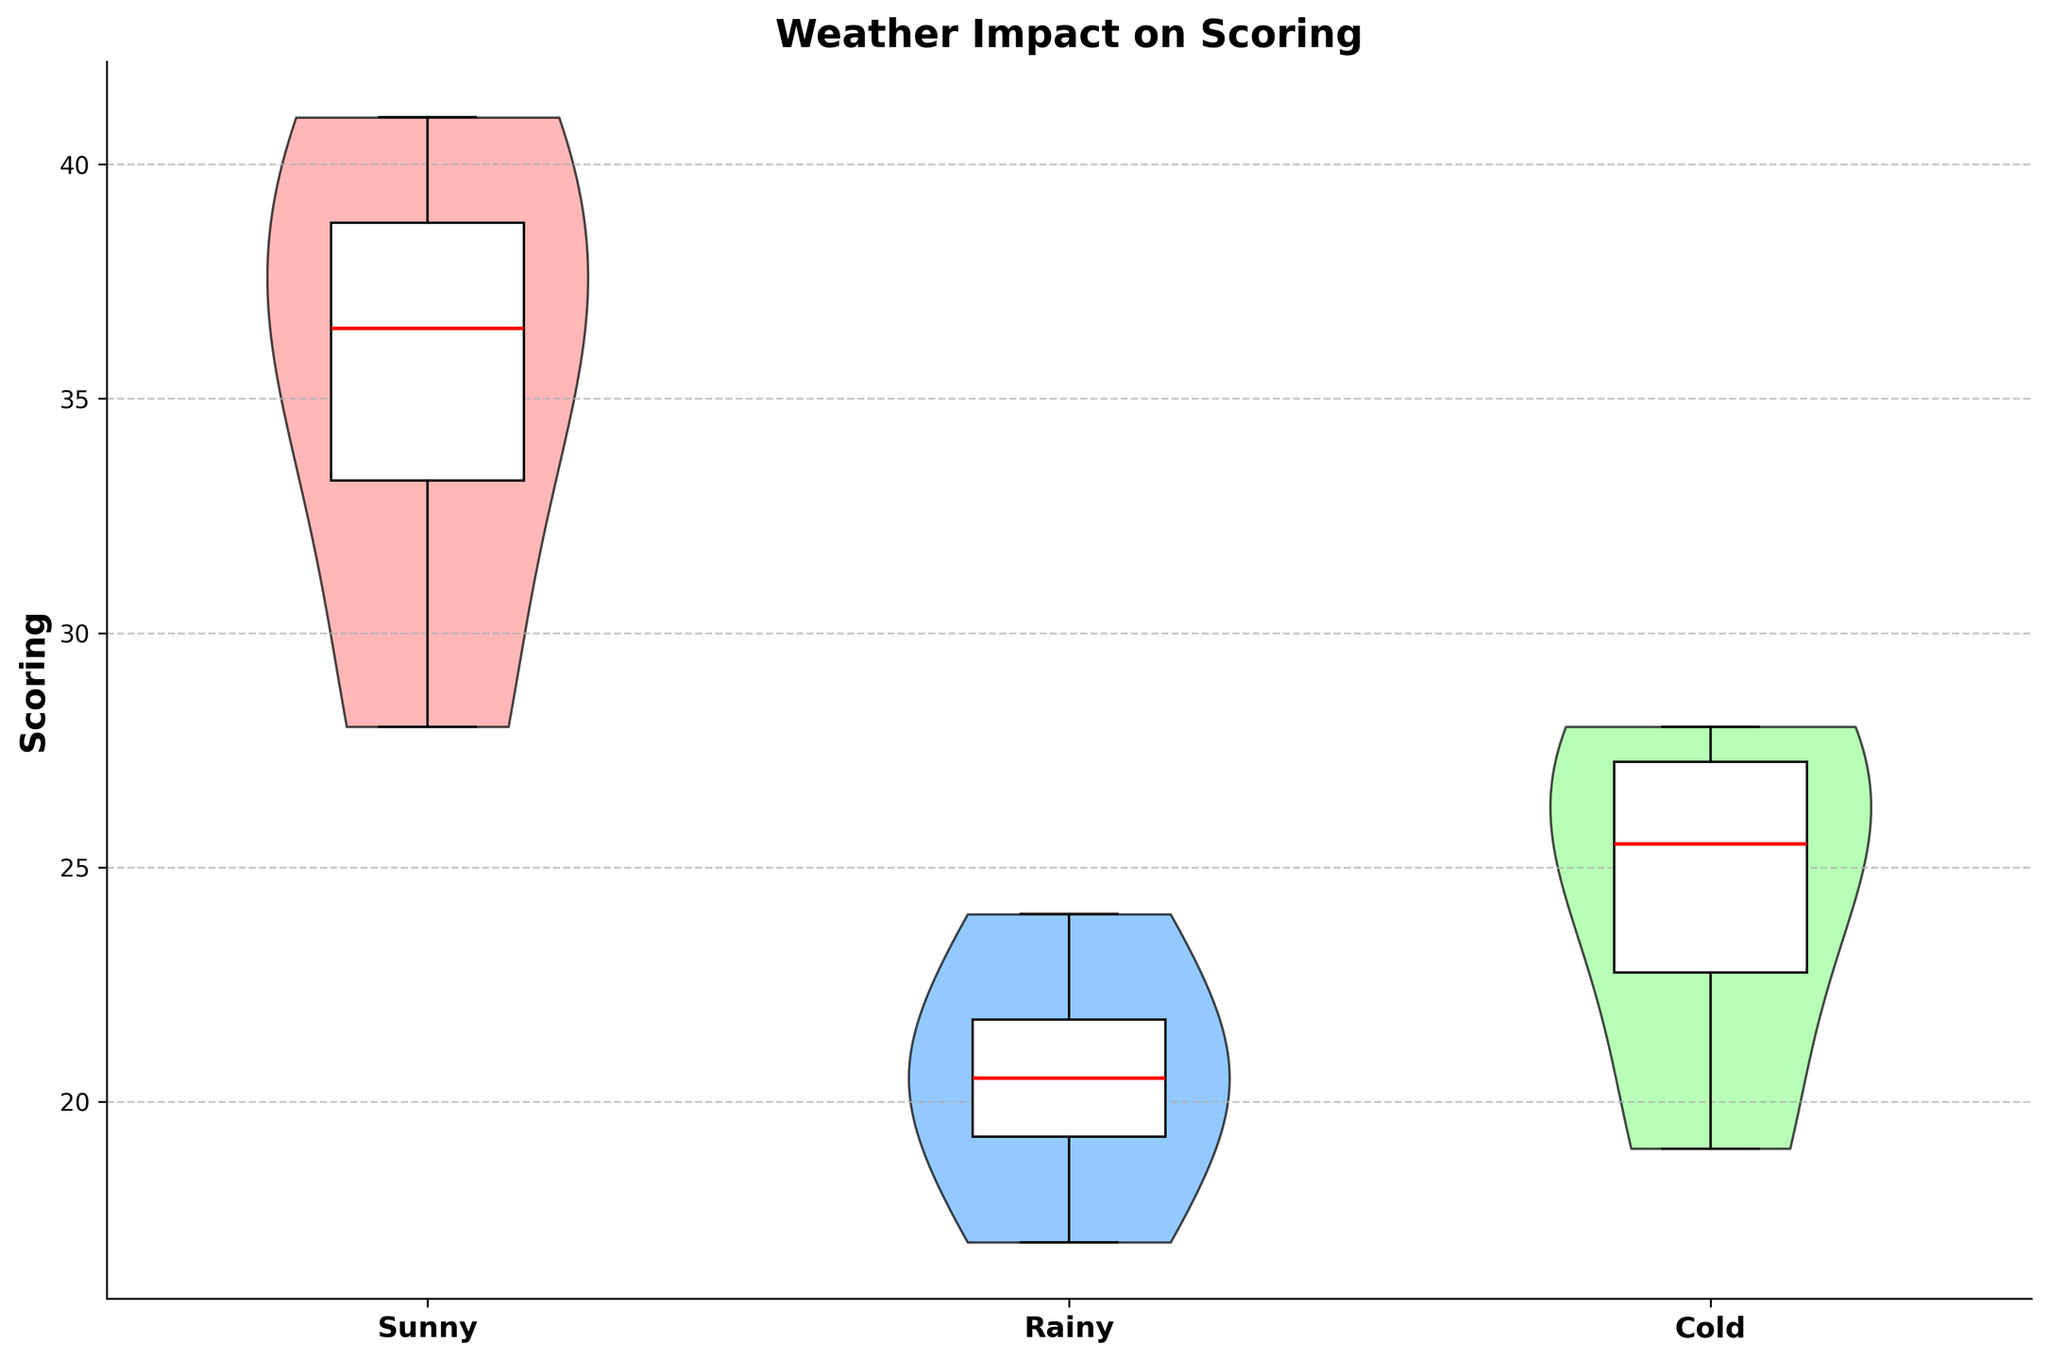What is the title of the figure? The title of the figure is typically displayed at the top of the chart and summarizes the main topic of the visualization. In this case, you should look at the top of the figure to find the displayed text.
Answer: Weather Impact on Scoring Which weather condition has the highest median scoring? Medians in a box plot are represented by bold horizontal lines within each box. Identify the weather condition where this line is at its highest position along the scoring axis.
Answer: Sunny How does the scoring under rainy conditions compare to sunny conditions? Compare the position and spread of the violin plots and box plots for rainy and sunny weather conditions. Notice where the majority of the data points cluster and how spread out they are.
Answer: Scoring is generally lower under rainy conditions than sunny conditions What is the range of scoring under cold weather conditions? The range can be observed by looking at the distance between the highest and lowest points of the violin or box plot for cold weather. Specifically, check the whiskers of the box plot for precise minimum and maximum values.
Answer: Approximately 19 to 28 points Which team has the highest average scoring, and where is it annotated on the figure? The highest average scoring team is usually indicated by the highest annotation on the right side of the chart. Check the annotated average values and identify the team associated with the highest one.
Answer: Ohio State Buckeyes at the top-right What statistical measure is represented by the red line within the box plots? In box plots, the red line typically represents the median value of the data. This is the midpoint of the values when they are ordered.
Answer: Median How many different weather conditions are analyzed? The weather conditions are listed on the x-axis. Count the distinct categories presented.
Answer: Three Compare the interquartile range (IQR) for scoring under sunny and rainy conditions. The IQR is the range between the first quartile (25th percentile) and the third quartile (75th percentile) within a box plot. Compare the length of the boxes for sunny and rainy conditions.
Answer: IQR is narrower for rainy conditions compared to sunny What does the black outline around the violin plots signify? The black outline typically signifies the range within which the data points are spread for each weather condition, illustrating the density of the data.
Answer: Data spread and density Explain the significance of the vertical position of the team annotations on the figure. The vertical position of the team annotations indicates the average scoring for each team across the weather conditions. The higher the position, the higher the average scoring.
Answer: Indicates team average scoring 